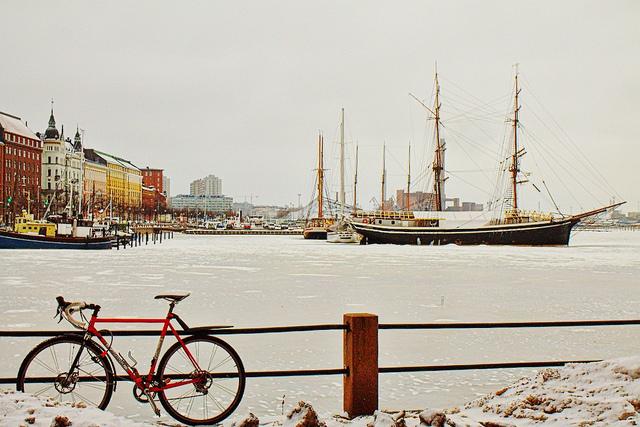How many boats?
Concise answer only. 3. Is there a person riding the bike?
Quick response, please. No. Is there snow on the ground?
Quick response, please. Yes. Is there a boat frozen in the water?
Short answer required. Yes. Are these boats powered by wind?
Keep it brief. Yes. What type of vehicle is that?
Write a very short answer. Boat. 